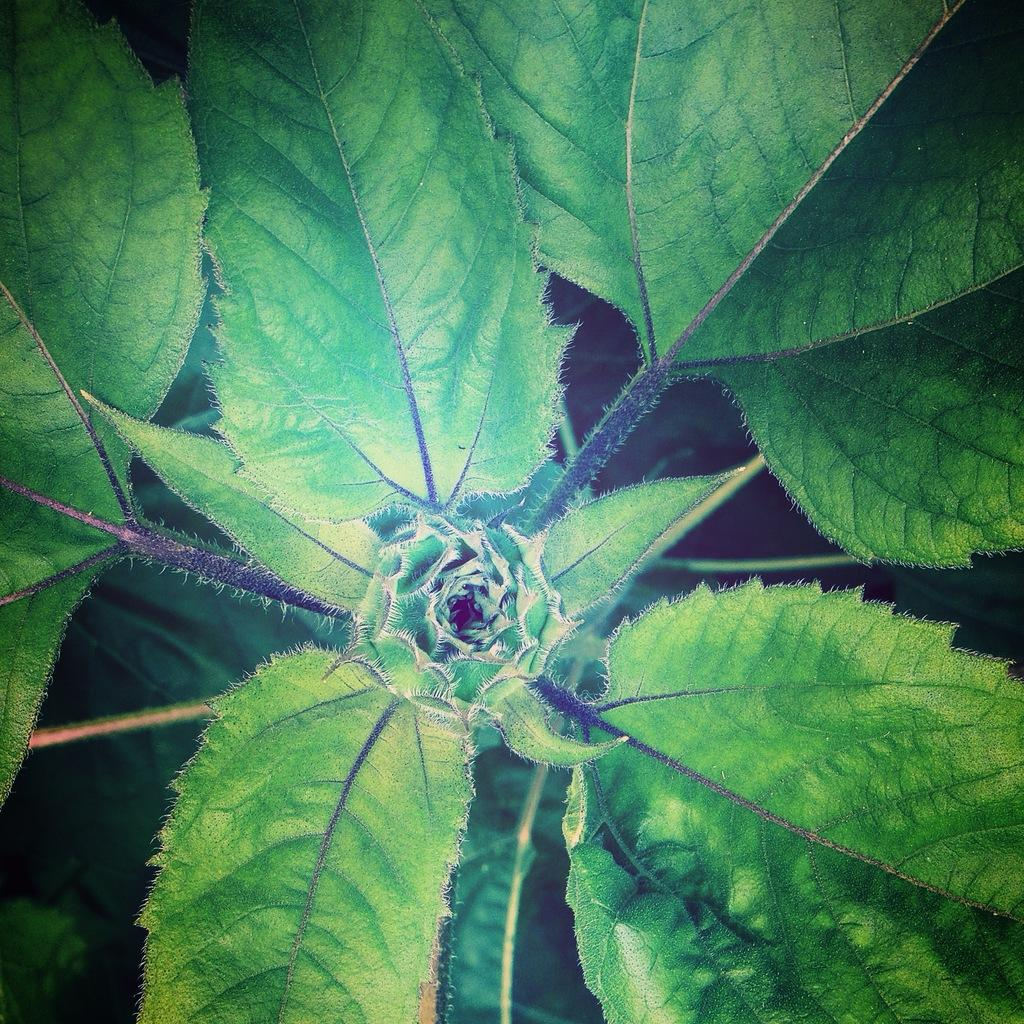What is present in the image? There is a plant in the image. Can you describe the appearance of the plant? The plant has green and black coloration. What feature can be found in the middle of the plant? There is a flower in the middle of the plant. What type of lettuce can be seen growing on the plant in the image? There is no lettuce present in the image; it features a plant with a flower in the middle. 